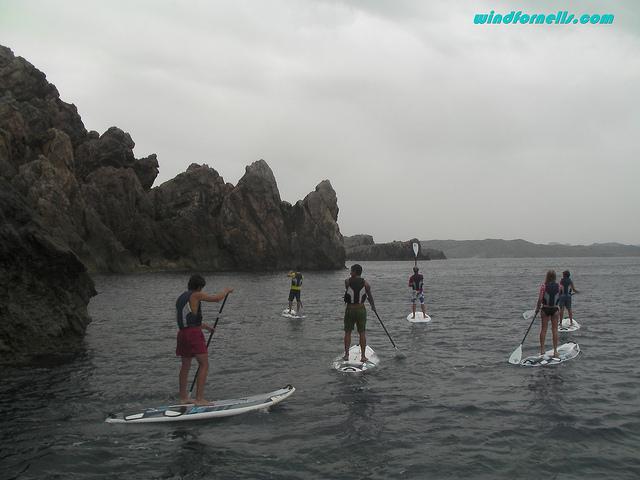What are they doing?
Quick response, please. Paddle boarding. What type of board are the people using?
Give a very brief answer. Surfboard. How many people are surfing?
Write a very short answer. 6. What is in the water?
Short answer required. Surfboards. 